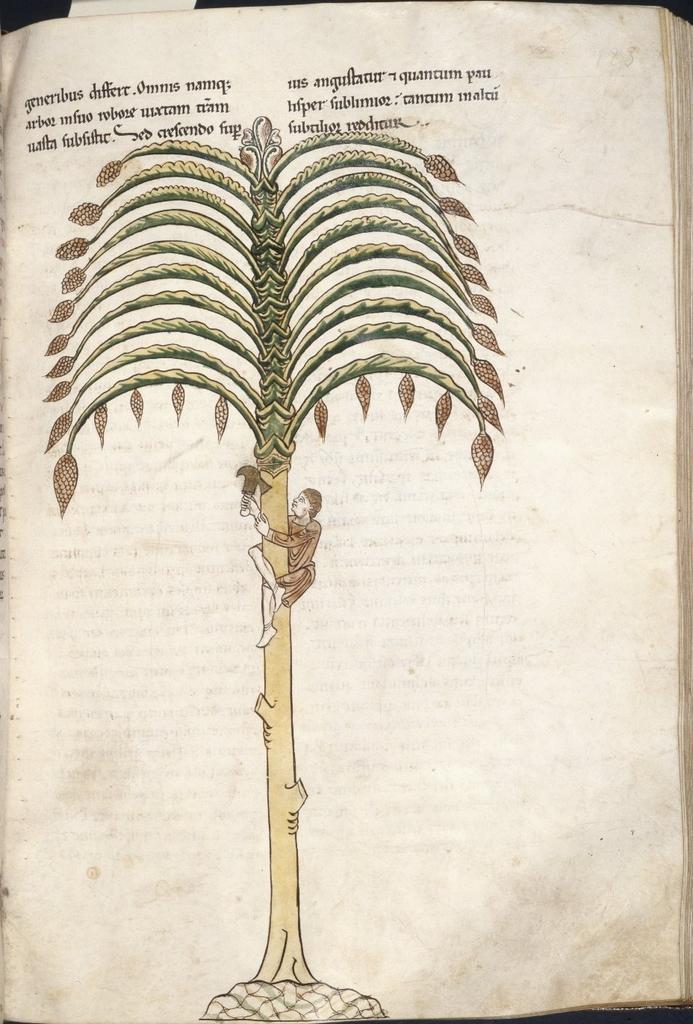Can you describe this image briefly? In this picture we can see a book. In the page we can see a man who is sitting on the tree and he is holding some objects. On the top we can see something is written. 